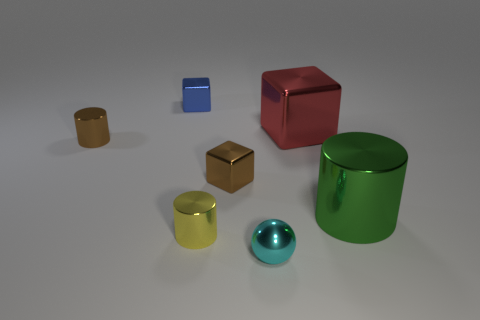Does the object on the right side of the big red cube have the same material as the tiny cyan object?
Your answer should be compact. Yes. How many shiny objects are to the right of the tiny blue object and left of the metal sphere?
Ensure brevity in your answer.  2. What is the color of the tiny cylinder that is on the left side of the metal cube behind the shiny cube on the right side of the brown metallic block?
Your response must be concise. Brown. What number of other things are the same shape as the red metal thing?
Offer a very short reply. 2. There is a tiny cylinder on the left side of the yellow object; are there any tiny cyan things behind it?
Ensure brevity in your answer.  No. How many metallic objects are either balls or large purple cylinders?
Offer a very short reply. 1. What is the material of the cylinder that is both behind the tiny yellow shiny cylinder and left of the red thing?
Your response must be concise. Metal. Are there any cyan metal objects behind the large green metallic thing in front of the small cube that is behind the large red block?
Your response must be concise. No. Is there anything else that has the same material as the large green cylinder?
Make the answer very short. Yes. There is a red thing that is made of the same material as the tiny yellow object; what is its shape?
Provide a succinct answer. Cube. 